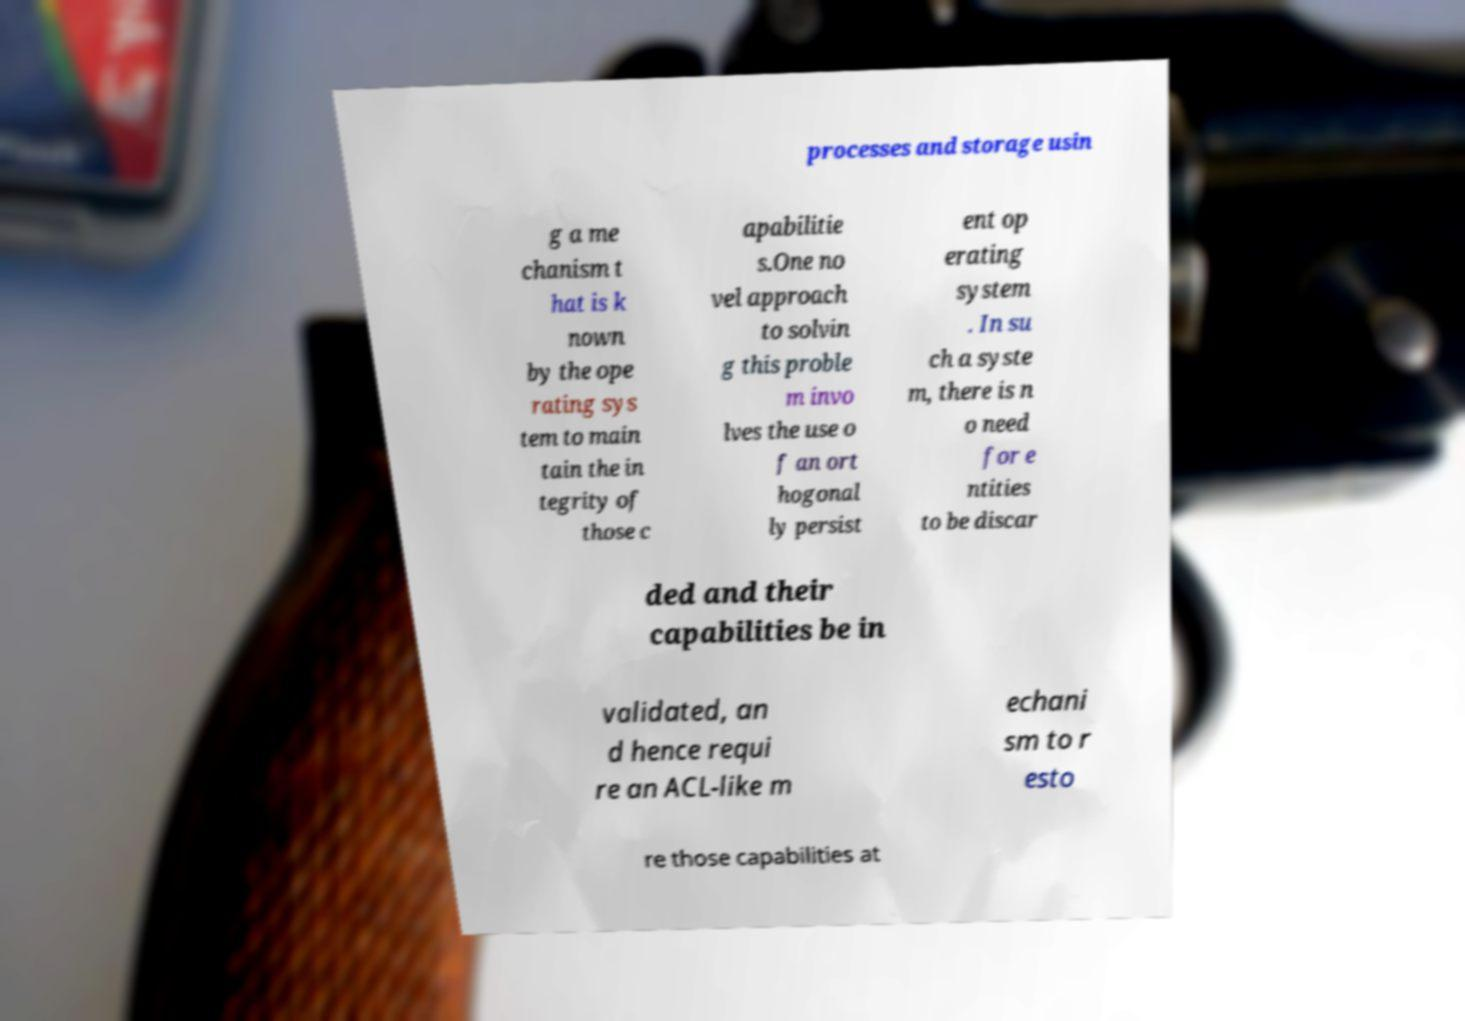Please read and relay the text visible in this image. What does it say? processes and storage usin g a me chanism t hat is k nown by the ope rating sys tem to main tain the in tegrity of those c apabilitie s.One no vel approach to solvin g this proble m invo lves the use o f an ort hogonal ly persist ent op erating system . In su ch a syste m, there is n o need for e ntities to be discar ded and their capabilities be in validated, an d hence requi re an ACL-like m echani sm to r esto re those capabilities at 